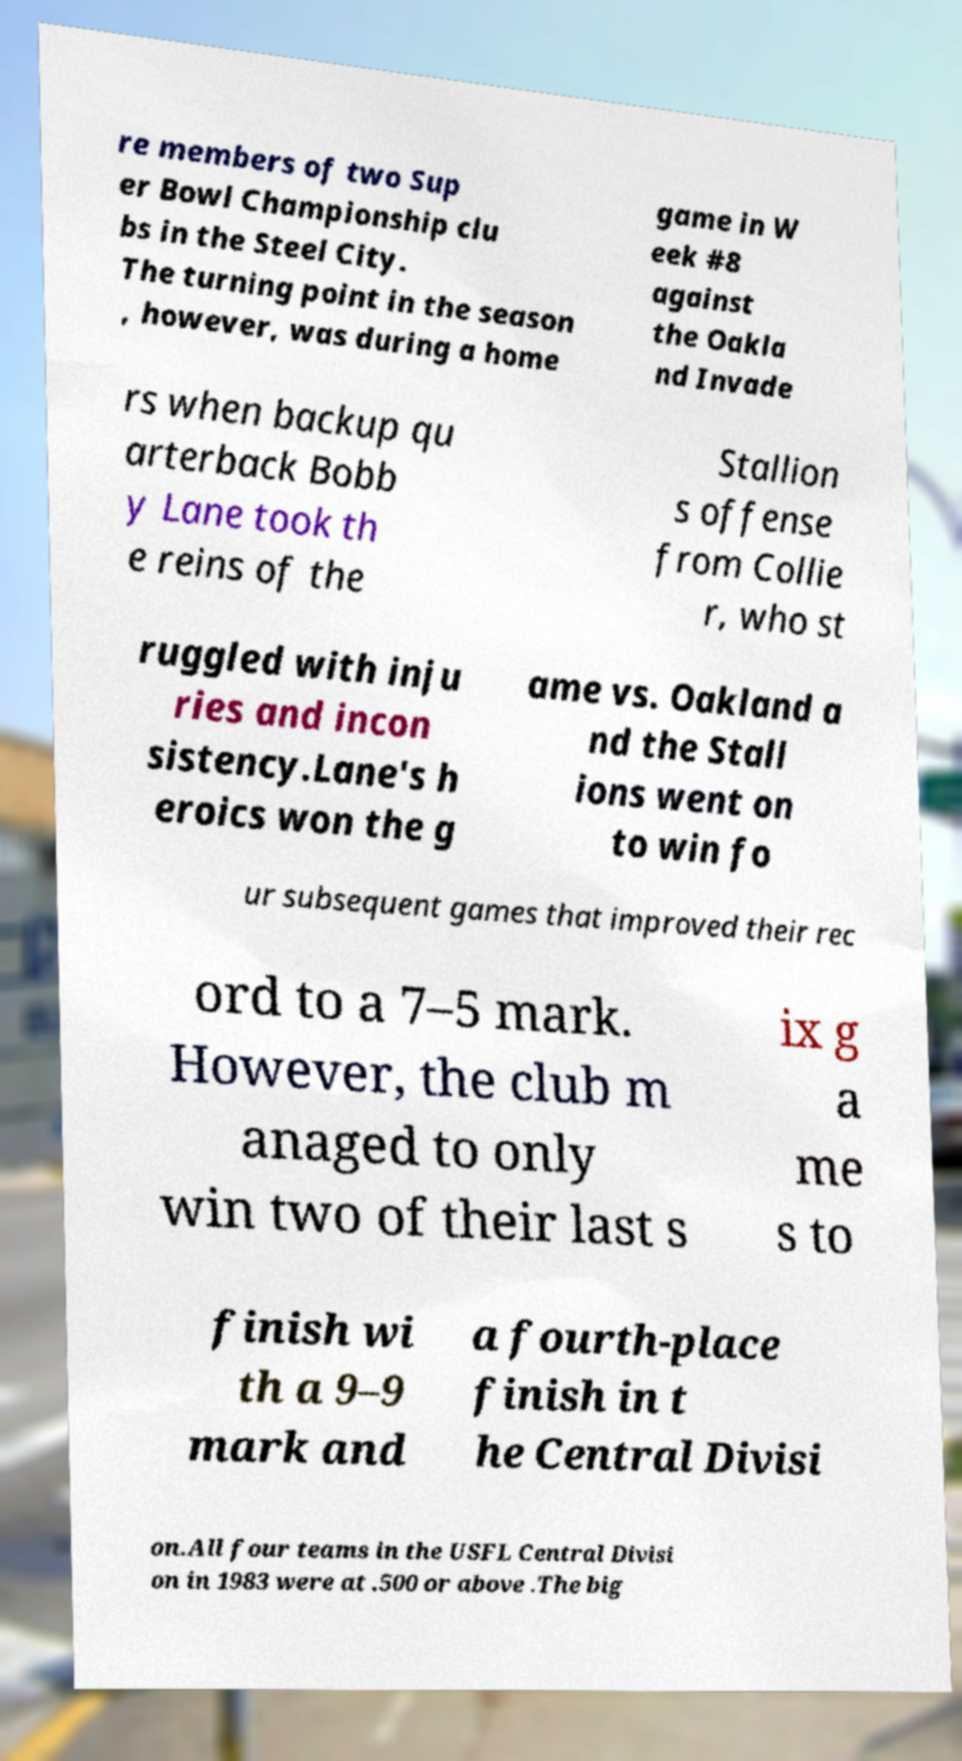Can you accurately transcribe the text from the provided image for me? re members of two Sup er Bowl Championship clu bs in the Steel City. The turning point in the season , however, was during a home game in W eek #8 against the Oakla nd Invade rs when backup qu arterback Bobb y Lane took th e reins of the Stallion s offense from Collie r, who st ruggled with inju ries and incon sistency.Lane's h eroics won the g ame vs. Oakland a nd the Stall ions went on to win fo ur subsequent games that improved their rec ord to a 7–5 mark. However, the club m anaged to only win two of their last s ix g a me s to finish wi th a 9–9 mark and a fourth-place finish in t he Central Divisi on.All four teams in the USFL Central Divisi on in 1983 were at .500 or above .The big 